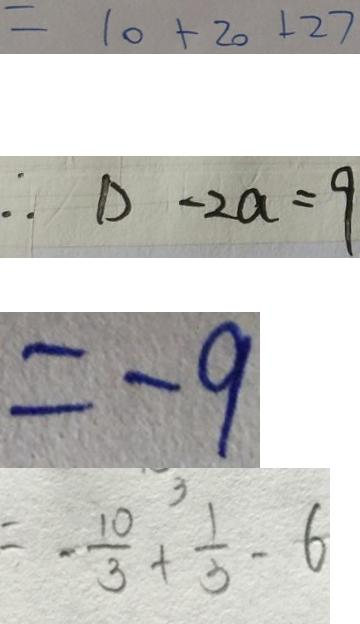Convert formula to latex. <formula><loc_0><loc_0><loc_500><loc_500>= 1 0 + 2 0 + 2 7 
 \therefore D - 2 a = 9 
 = - 9 
 = - \frac { 1 0 } { 3 } + \frac { 1 } { 3 } - 6</formula> 